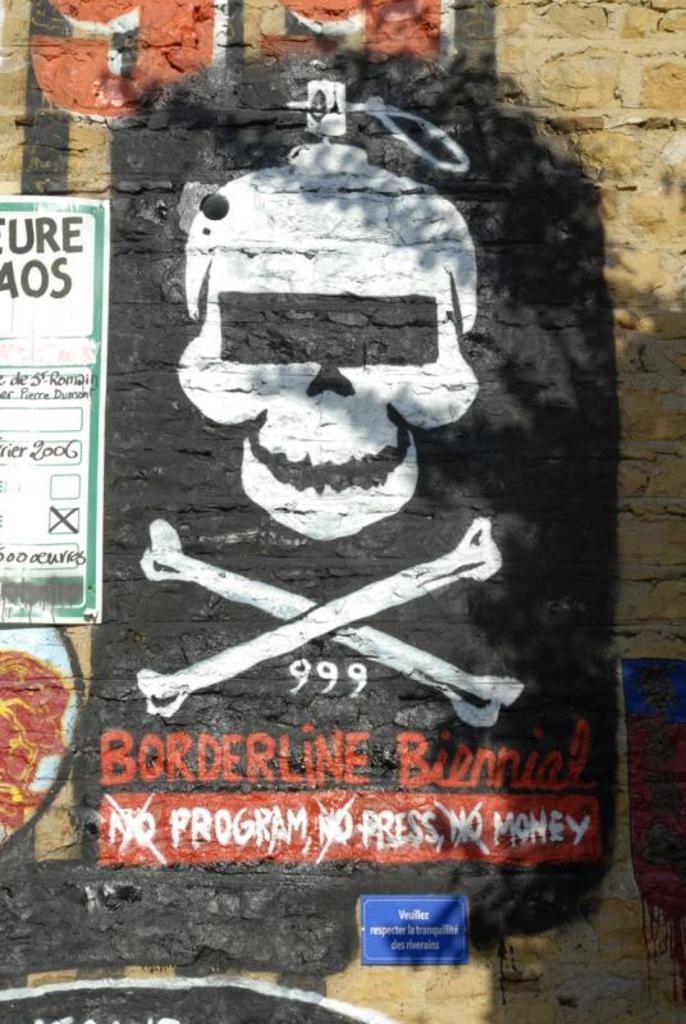What type of artwork is present on the wall in the image? There are paintings on the wall in the image. What other item can be seen on the wall in the image? There is a poster on the wall in the image. What is the third item on the wall in the image? There is a board on the wall in the image. What company is represented by the logo on the board in the image? There is no logo or company mentioned in the image; it only features paintings, a poster, and a board. How many points are visible on the poster in the image? The poster in the image does not have any points; it is a single image or design. 